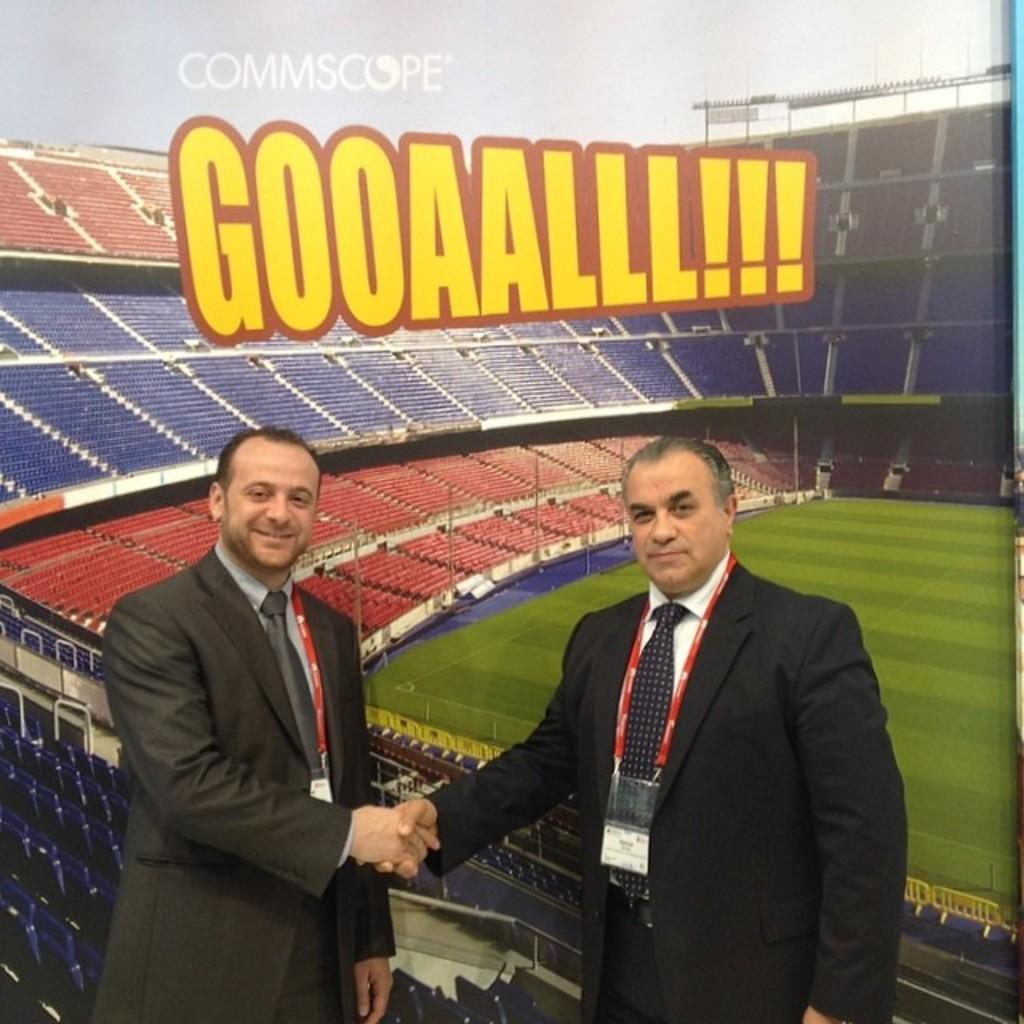How many people are in the image? There are 2 people in the image. What are the people doing in the image? The people are standing. What are the people wearing in the image? The people are wearing suits. Do the people have any identification in the image? Yes, the people have ID cards. What can be seen in the background of the image? There is a banner of a stadium in the background. Are there any waves visible in the image? There are no waves present in the image, as it features two people standing and wearing suits with a stadium banner in the background. 